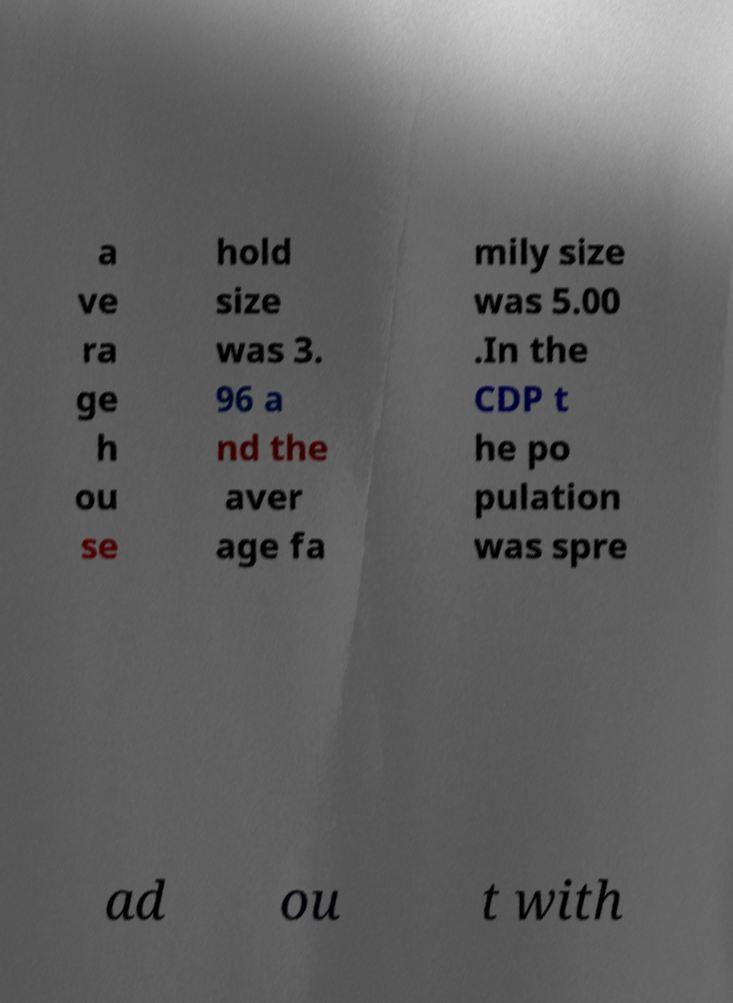Can you accurately transcribe the text from the provided image for me? a ve ra ge h ou se hold size was 3. 96 a nd the aver age fa mily size was 5.00 .In the CDP t he po pulation was spre ad ou t with 